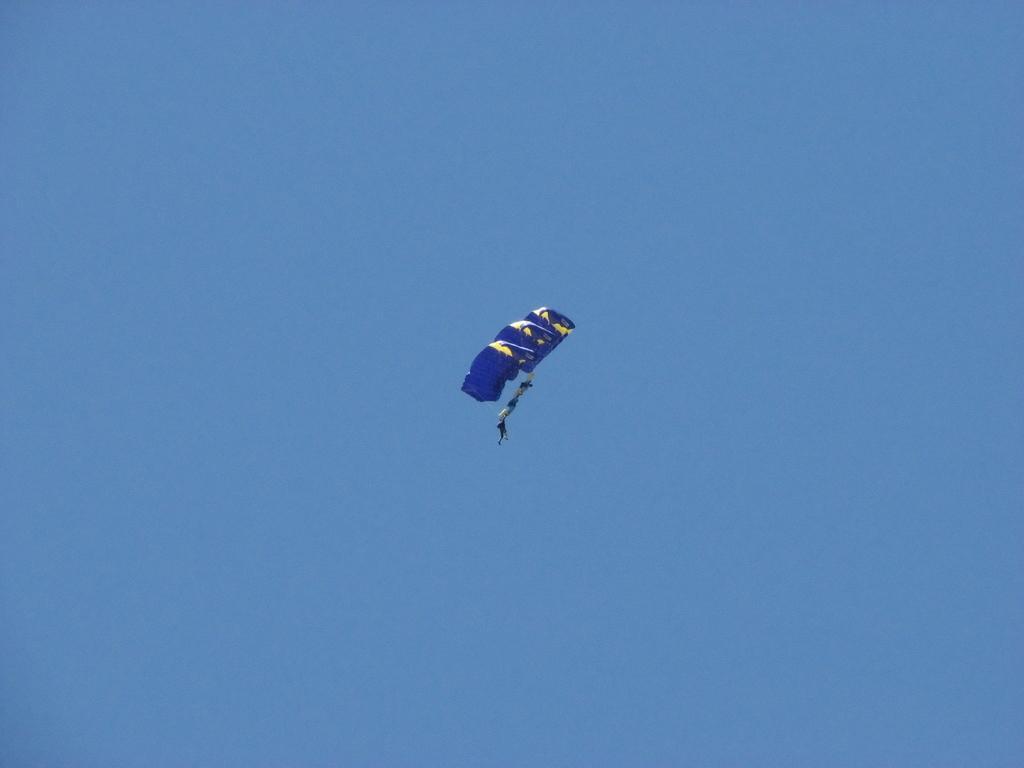Can you describe this image briefly? In the middle of the image we can see few parachutes and group of people in the air. 